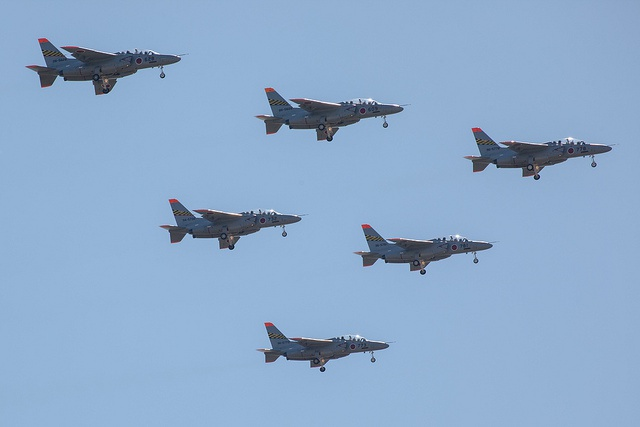Describe the objects in this image and their specific colors. I can see airplane in darkgray, gray, blue, lightblue, and black tones, airplane in darkgray, gray, lightblue, blue, and black tones, airplane in darkgray, gray, blue, and black tones, airplane in darkgray, gray, blue, and black tones, and airplane in darkgray, gray, blue, black, and lightblue tones in this image. 